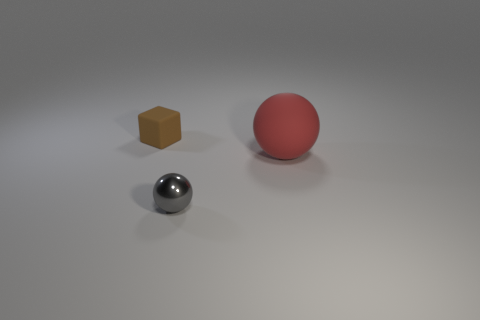Is there anything else that has the same size as the red rubber thing?
Ensure brevity in your answer.  No. Is the number of tiny matte blocks that are behind the big matte sphere greater than the number of big blue shiny balls?
Your answer should be compact. Yes. The thing to the left of the tiny thing to the right of the brown thing is what color?
Provide a short and direct response. Brown. What number of things are tiny objects that are in front of the brown matte block or rubber objects in front of the small brown object?
Your answer should be very brief. 2. What color is the matte sphere?
Give a very brief answer. Red. How many red things have the same material as the big red ball?
Make the answer very short. 0. Is the number of tiny yellow metal cylinders greater than the number of large red balls?
Your response must be concise. No. What number of tiny metal things are to the right of the tiny object that is right of the small brown rubber cube?
Provide a short and direct response. 0. What number of things are spheres that are behind the tiny gray metallic sphere or gray objects?
Give a very brief answer. 2. Are there any big matte objects that have the same shape as the tiny metallic thing?
Provide a succinct answer. Yes. 